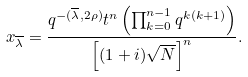<formula> <loc_0><loc_0><loc_500><loc_500>x _ { \overline { \lambda } } = \frac { q ^ { - ( \overline { \lambda } , 2 \rho ) } t ^ { n } \left ( \prod _ { k = 0 } ^ { n - 1 } q ^ { k ( k + 1 ) } \right ) } { \left [ ( 1 + i ) \sqrt { N } \right ] ^ { n } } .</formula> 